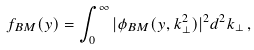<formula> <loc_0><loc_0><loc_500><loc_500>f _ { B M } ( y ) = \int _ { 0 } ^ { \infty } | \phi _ { B M } ( y , k _ { \perp } ^ { 2 } ) | ^ { 2 } d ^ { 2 } k _ { \perp } \, ,</formula> 